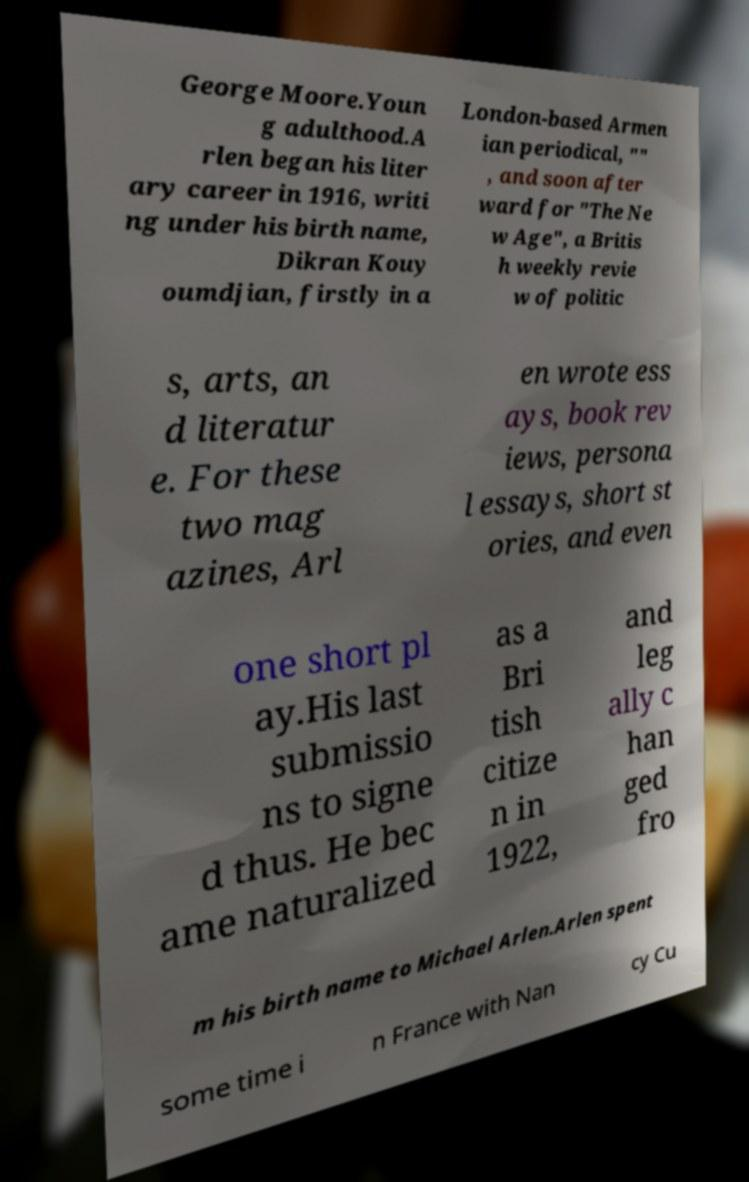What messages or text are displayed in this image? I need them in a readable, typed format. George Moore.Youn g adulthood.A rlen began his liter ary career in 1916, writi ng under his birth name, Dikran Kouy oumdjian, firstly in a London-based Armen ian periodical, "" , and soon after ward for "The Ne w Age", a Britis h weekly revie w of politic s, arts, an d literatur e. For these two mag azines, Arl en wrote ess ays, book rev iews, persona l essays, short st ories, and even one short pl ay.His last submissio ns to signe d thus. He bec ame naturalized as a Bri tish citize n in 1922, and leg ally c han ged fro m his birth name to Michael Arlen.Arlen spent some time i n France with Nan cy Cu 